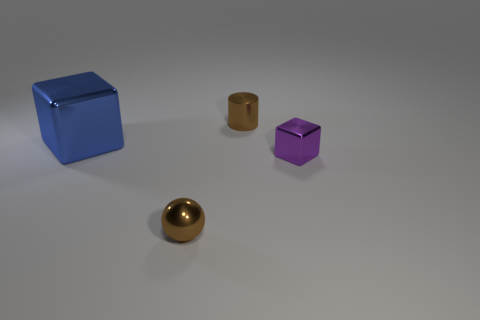How many other things are there of the same color as the small cylinder?
Make the answer very short. 1. Does the tiny sphere have the same color as the small cylinder that is on the right side of the sphere?
Offer a terse response. Yes. There is a object that is to the left of the metallic sphere; is it the same shape as the purple object?
Your answer should be compact. Yes. What number of things are both to the right of the blue object and in front of the tiny brown metallic cylinder?
Your answer should be very brief. 2. What shape is the tiny brown object that is to the right of the brown sphere?
Provide a short and direct response. Cylinder. What number of brown things have the same material as the brown sphere?
Ensure brevity in your answer.  1. Is the shape of the purple thing the same as the big metal thing that is in front of the metallic cylinder?
Keep it short and to the point. Yes. There is a small brown shiny object to the right of the tiny shiny thing that is left of the cylinder; are there any blue cubes that are in front of it?
Keep it short and to the point. Yes. There is a block that is on the left side of the cylinder; how big is it?
Give a very brief answer. Large. What material is the purple thing that is the same size as the cylinder?
Give a very brief answer. Metal. 